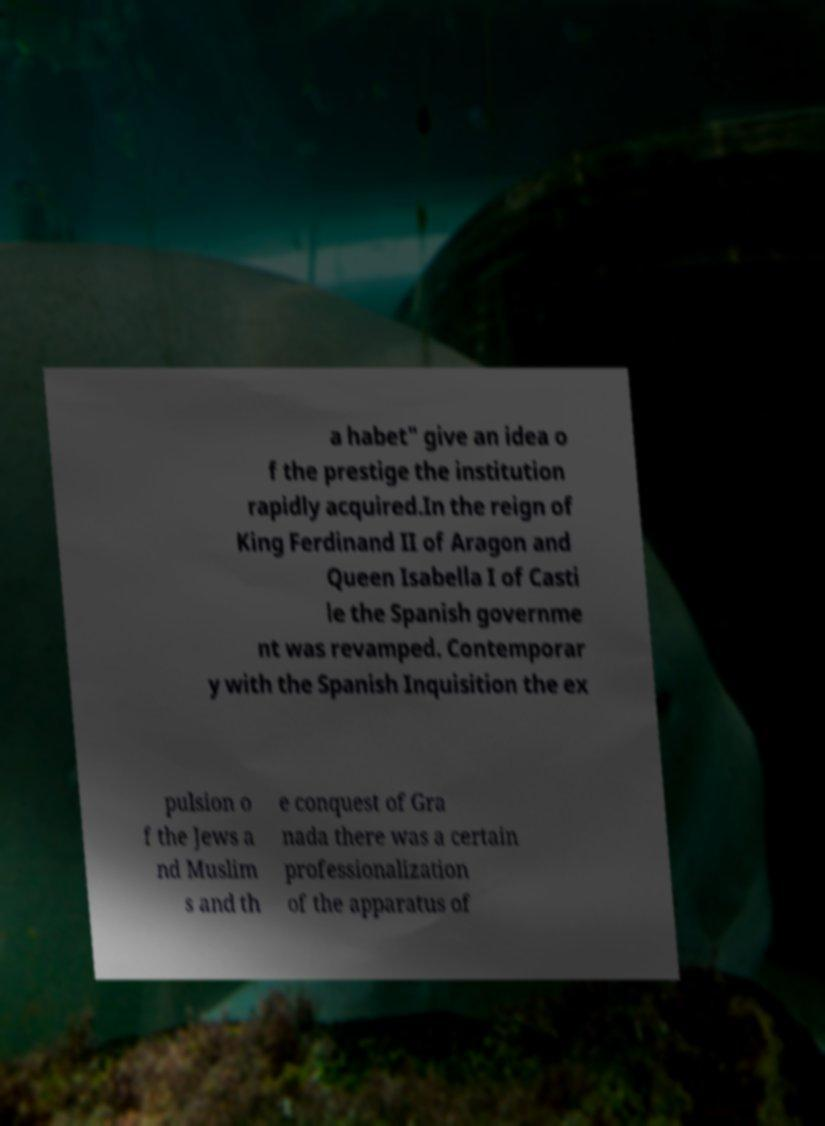Could you assist in decoding the text presented in this image and type it out clearly? a habet" give an idea o f the prestige the institution rapidly acquired.In the reign of King Ferdinand II of Aragon and Queen Isabella I of Casti le the Spanish governme nt was revamped. Contemporar y with the Spanish Inquisition the ex pulsion o f the Jews a nd Muslim s and th e conquest of Gra nada there was a certain professionalization of the apparatus of 